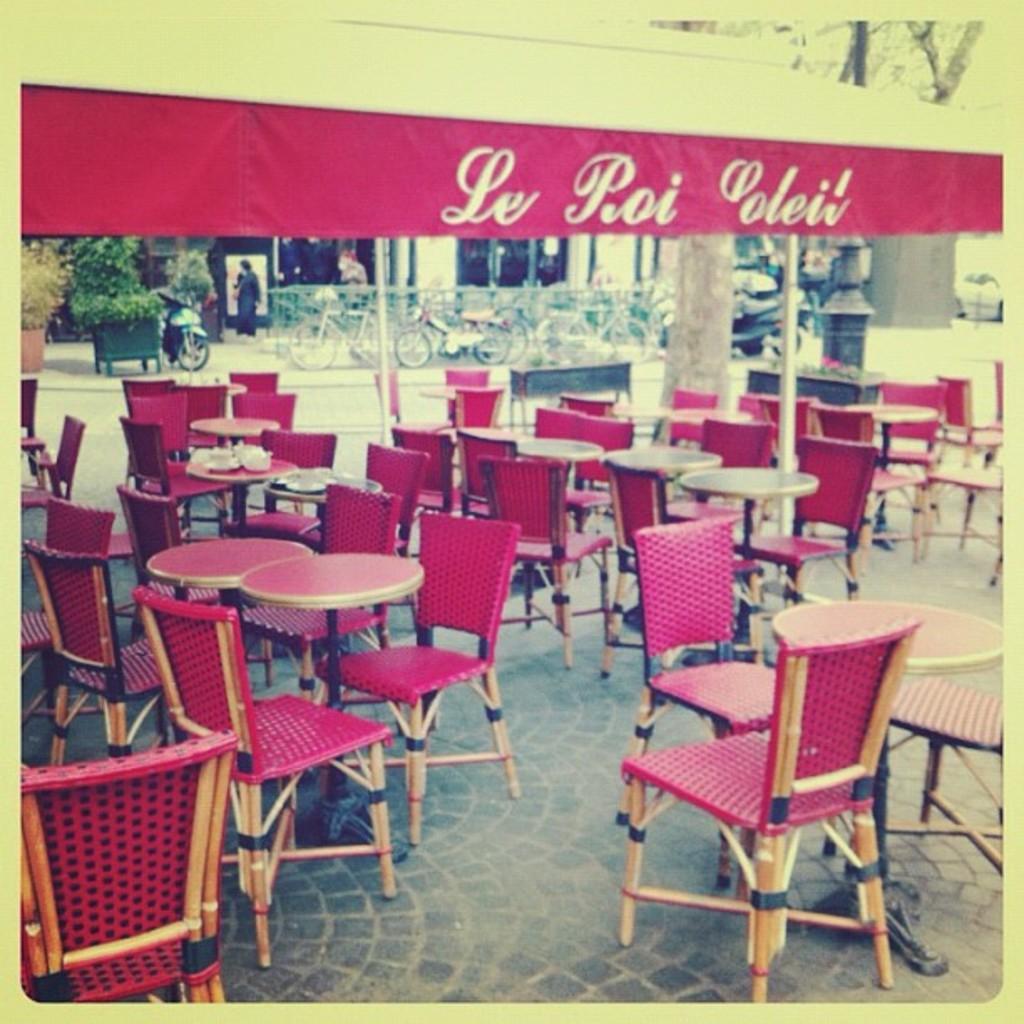Please provide a concise description of this image. In this image we can see there are few tables and chairs arranged on the surface. In the background there are few vehicles parked, trees, building and there are few people walking on the pavement. 